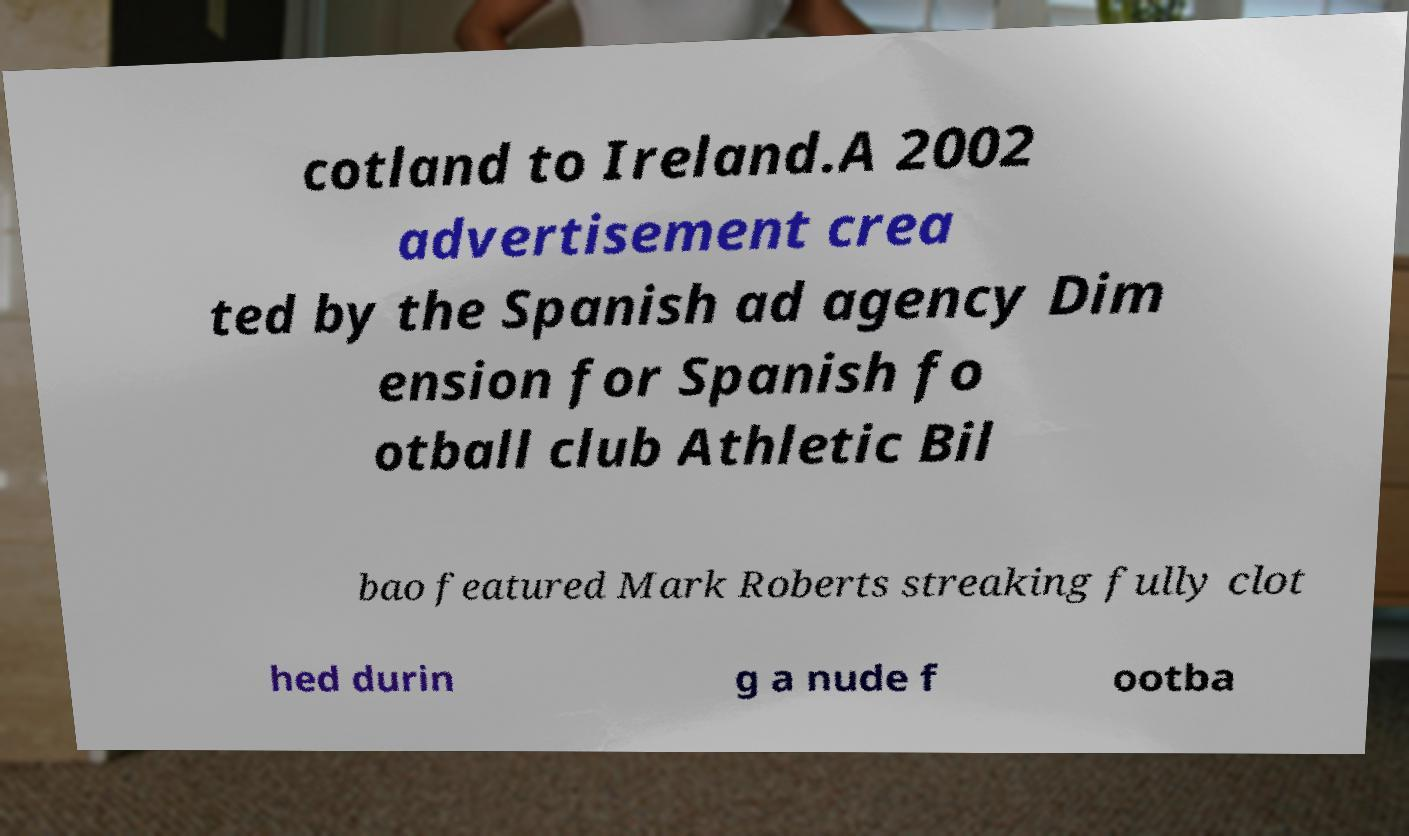Please identify and transcribe the text found in this image. cotland to Ireland.A 2002 advertisement crea ted by the Spanish ad agency Dim ension for Spanish fo otball club Athletic Bil bao featured Mark Roberts streaking fully clot hed durin g a nude f ootba 